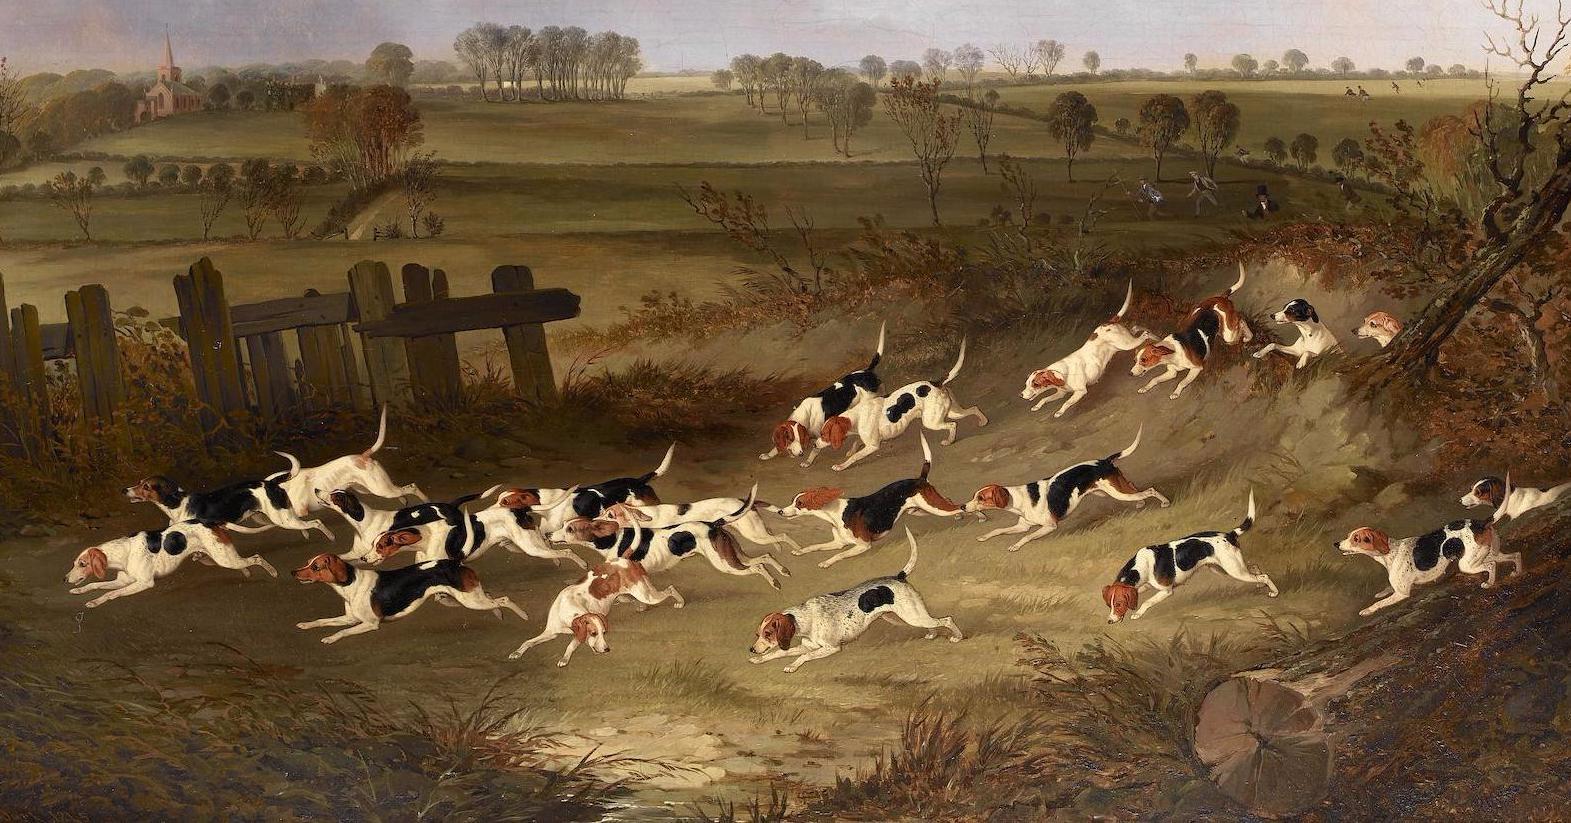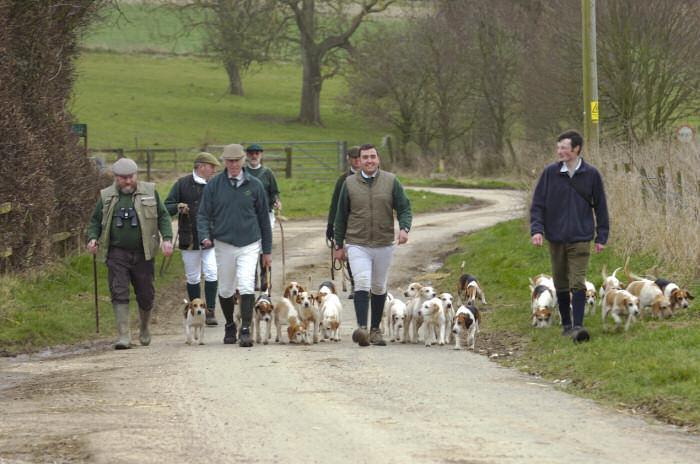The first image is the image on the left, the second image is the image on the right. Given the left and right images, does the statement "In one image, men wearing hunting clothes are with a pack of dogs adjacent to a stone wall." hold true? Answer yes or no. No. The first image is the image on the left, the second image is the image on the right. Considering the images on both sides, is "An image shows a group of at least five people walking with a pack of dogs." valid? Answer yes or no. Yes. 